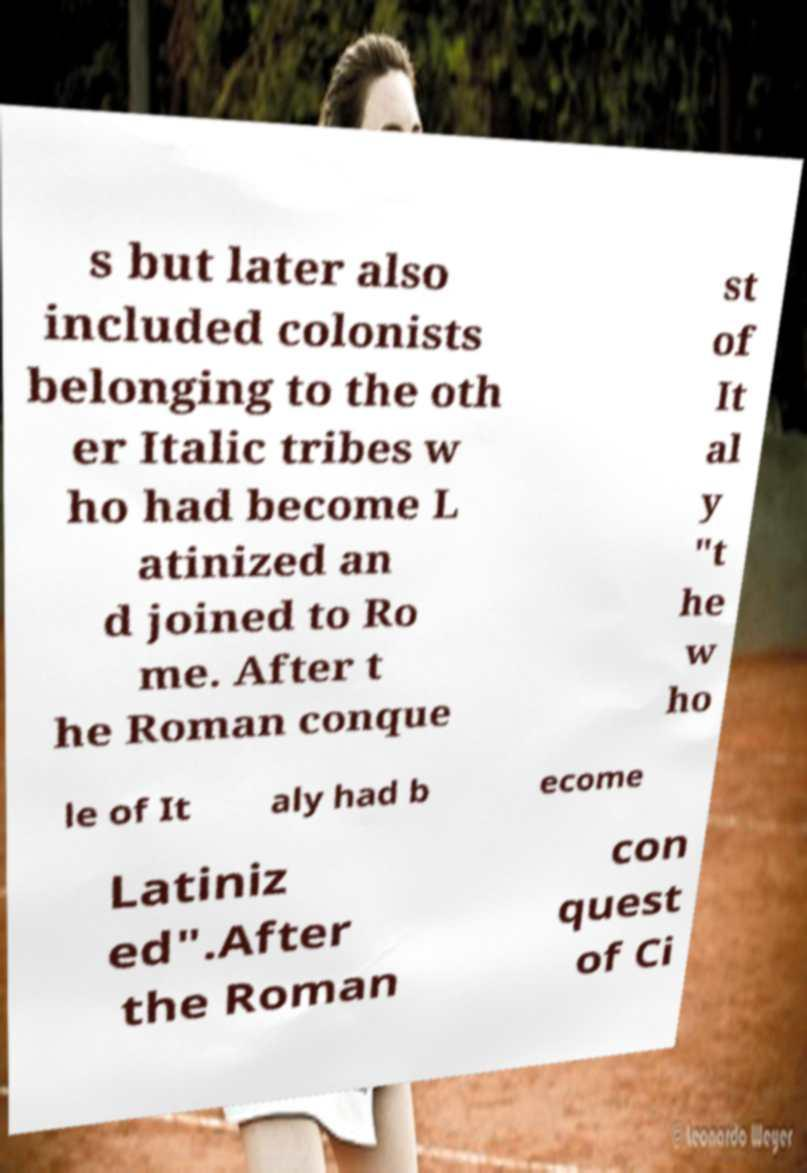For documentation purposes, I need the text within this image transcribed. Could you provide that? s but later also included colonists belonging to the oth er Italic tribes w ho had become L atinized an d joined to Ro me. After t he Roman conque st of It al y "t he w ho le of It aly had b ecome Latiniz ed".After the Roman con quest of Ci 